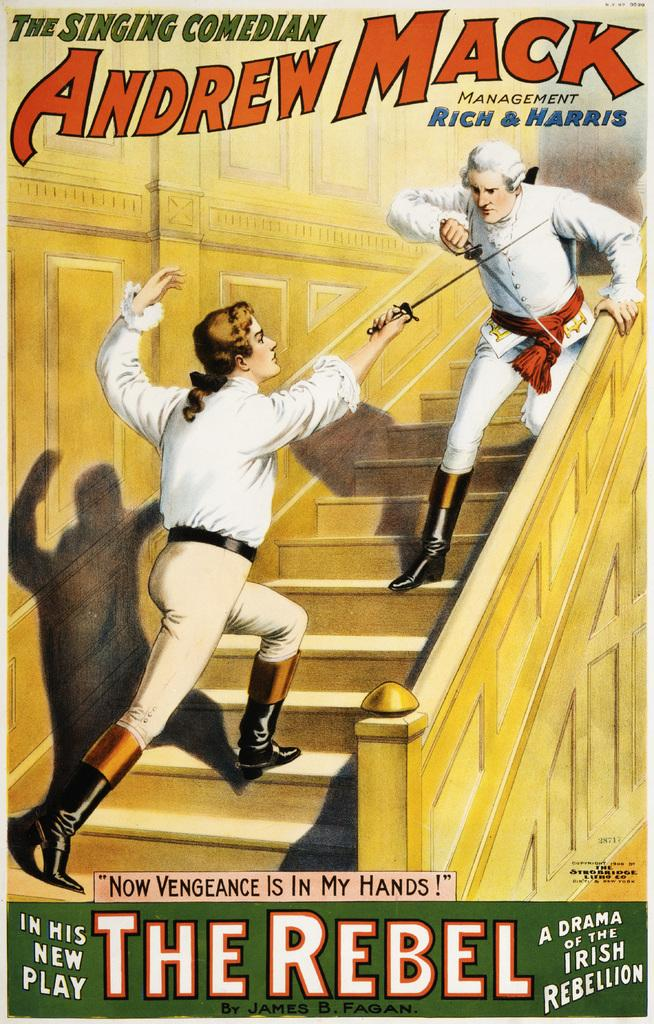<image>
Describe the image concisely. A poster of Andrew Mack's play called The Rebel 